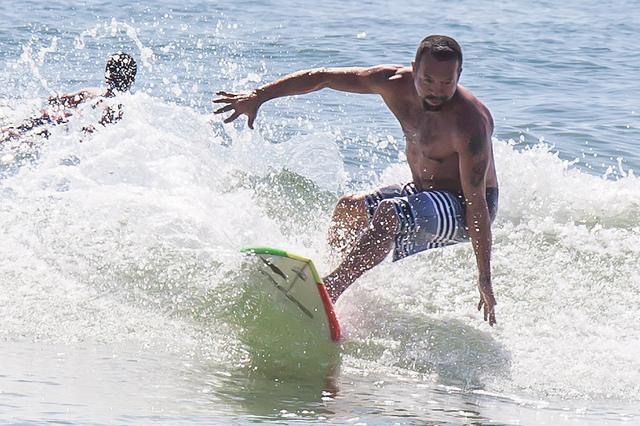What is the surfer doing to the wave? Please explain your reasoning. carving. The surfer is carving. 